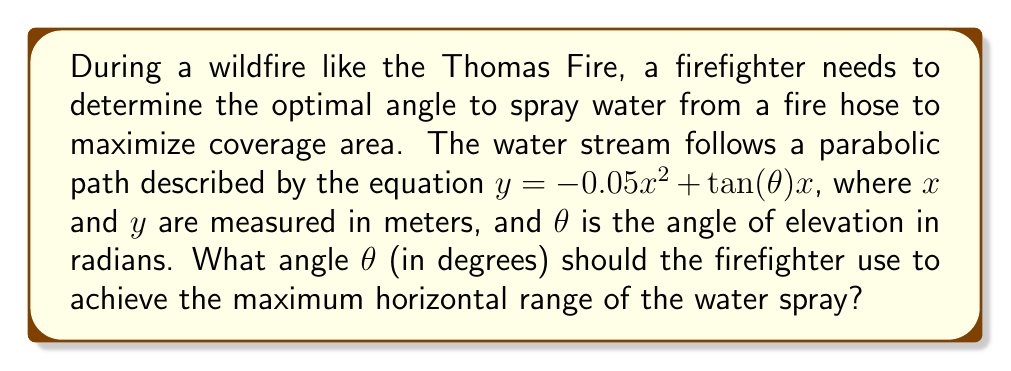What is the answer to this math problem? To solve this problem, we'll follow these steps:

1) The horizontal range is maximized when the water stream reaches its highest point. At this point, the derivative $\frac{dy}{dx} = 0$.

2) Let's find the derivative of the given function:
   $$\frac{dy}{dx} = -0.1x + \tan(\theta)$$

3) Set this equal to zero and solve for x:
   $$-0.1x + \tan(\theta) = 0$$
   $$0.1x = \tan(\theta)$$
   $$x = 10\tan(\theta)$$

4) This x-value represents half of the total horizontal range. The full range R is twice this:
   $$R = 2x = 20\tan(\theta)$$

5) To maximize R, we need to maximize $\tan(\theta)$. The maximum value of tangent occurs when $\theta = 45°$ or $\frac{\pi}{4}$ radians.

6) We can verify this by taking the derivative of R with respect to $\theta$:
   $$\frac{dR}{d\theta} = 20\sec^2(\theta)$$

   Setting this to zero:
   $$20\sec^2(\theta) = 0$$
   
   This equation has no solution, but $\sec^2(\theta)$ is minimized when $\theta = 45°$.

7) Therefore, the optimal angle for maximum range is 45°.
Answer: The optimal angle $\theta$ for maximum horizontal range is 45°. 